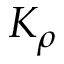<formula> <loc_0><loc_0><loc_500><loc_500>K _ { \rho }</formula> 